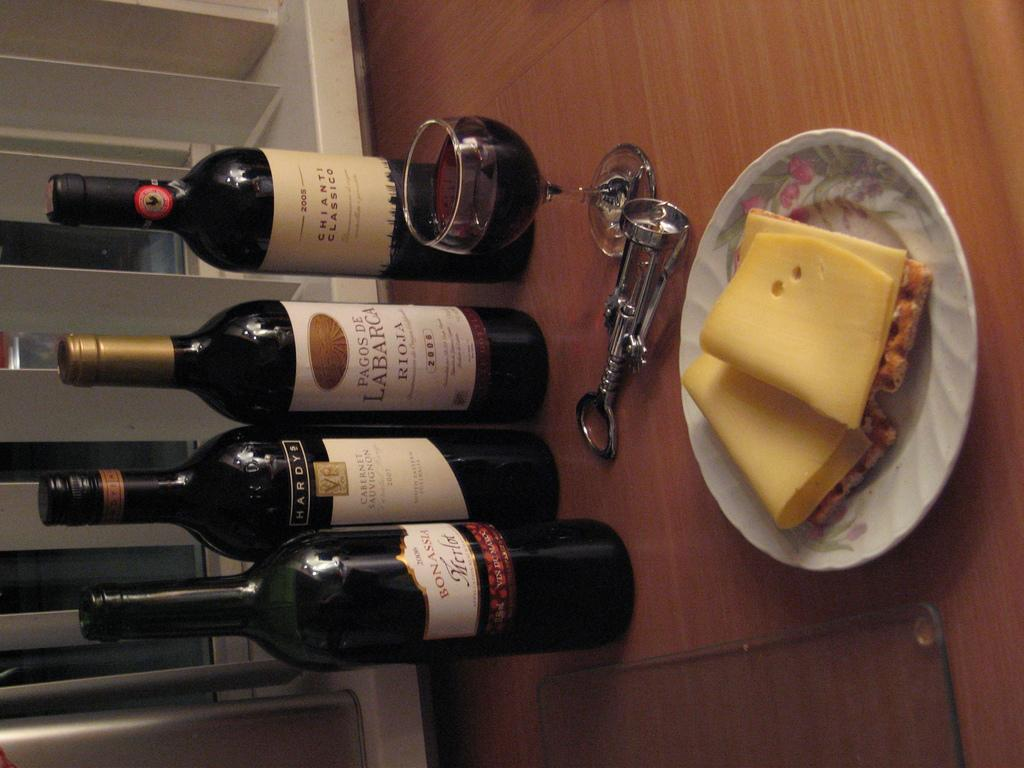What type of bottles are present in the image? There are wine bottles with stickers in the image. What can be seen in the image that might be used for drinking? There is a glass in the image. What tool is visible that could be used to open the wine bottles? There is a cork opener in the image. What is on the plate in the image? There is food on the plate in the image. What is the color of the surface on which the objects are placed? The objects are on a brown color surface. How many frogs are sitting on the plate in the image? There are no frogs present in the image; the plate contains food. What type of boot is visible in the image? There is no boot present in the image. 